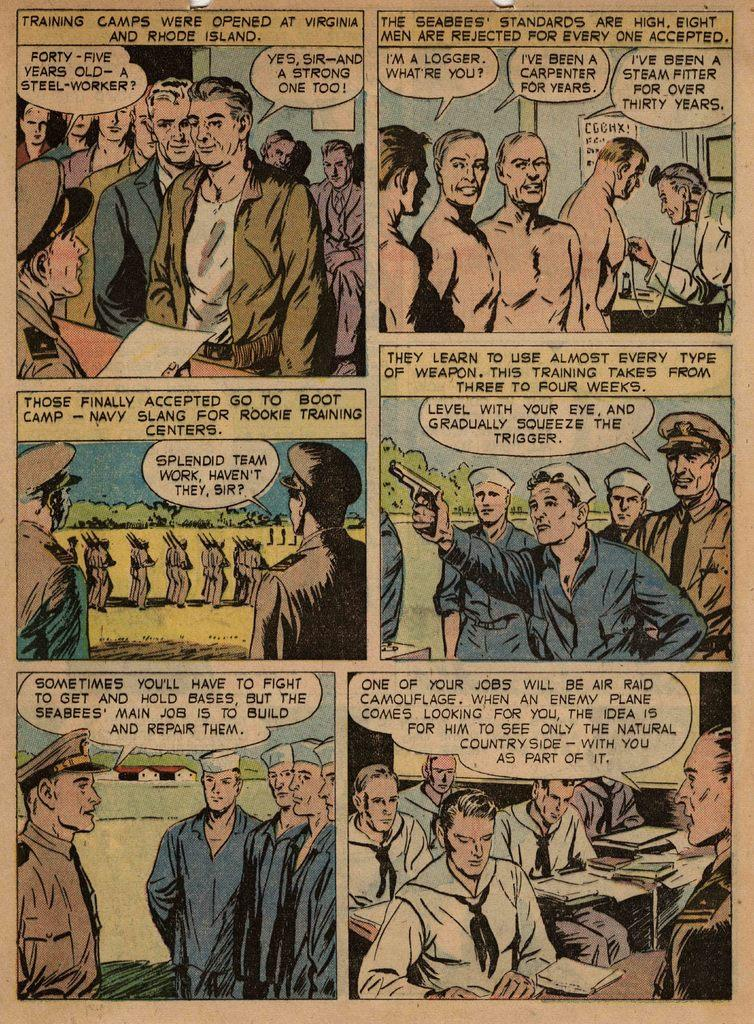<image>
Create a compact narrative representing the image presented. Comic page about a forty-five year old steel worker. 